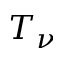Convert formula to latex. <formula><loc_0><loc_0><loc_500><loc_500>T _ { \nu }</formula> 